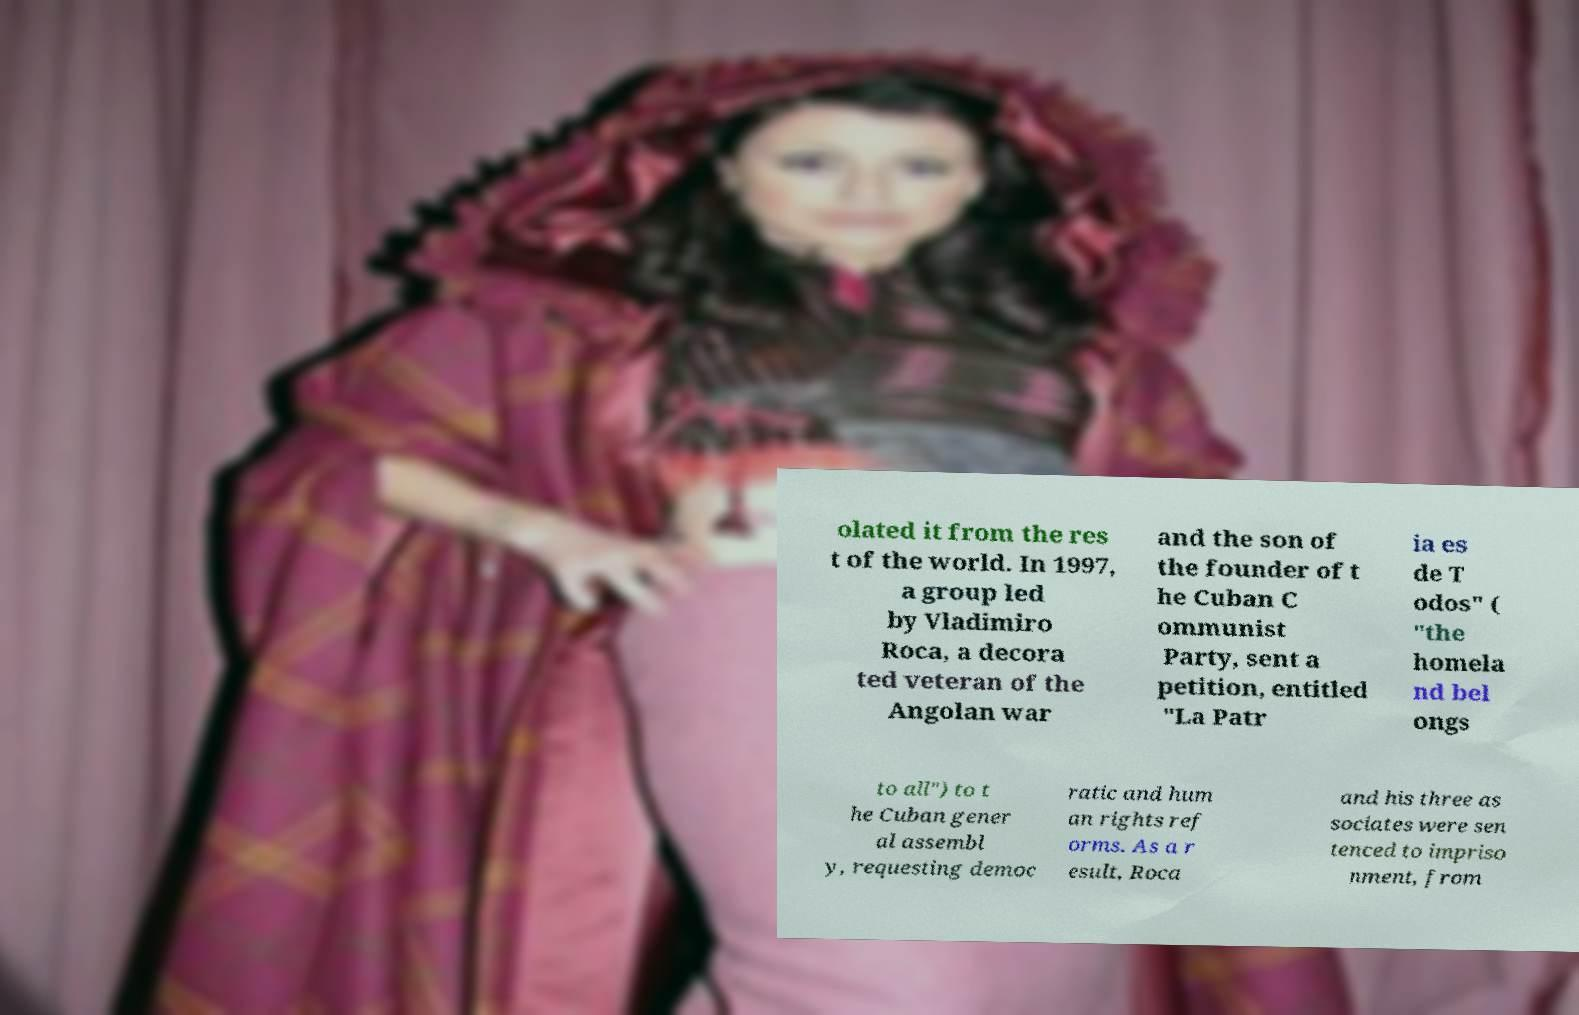Please read and relay the text visible in this image. What does it say? olated it from the res t of the world. In 1997, a group led by Vladimiro Roca, a decora ted veteran of the Angolan war and the son of the founder of t he Cuban C ommunist Party, sent a petition, entitled "La Patr ia es de T odos" ( "the homela nd bel ongs to all") to t he Cuban gener al assembl y, requesting democ ratic and hum an rights ref orms. As a r esult, Roca and his three as sociates were sen tenced to impriso nment, from 